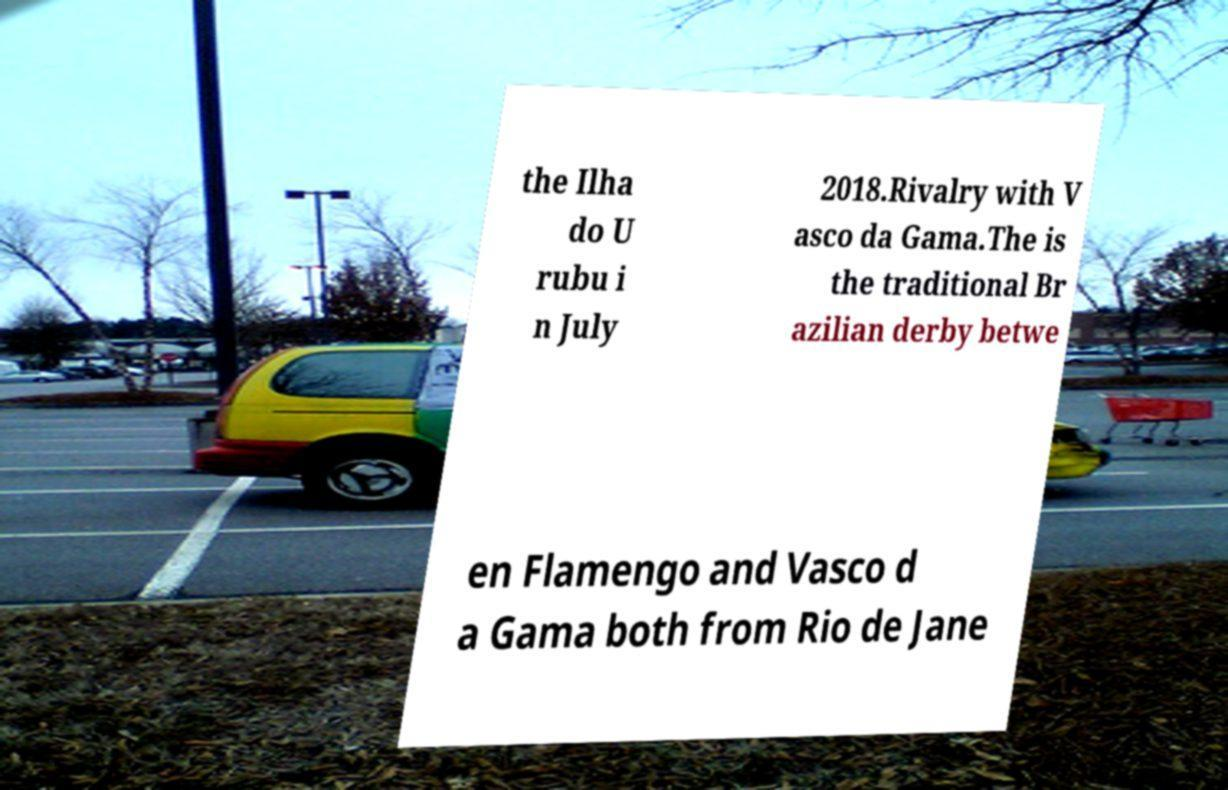I need the written content from this picture converted into text. Can you do that? the Ilha do U rubu i n July 2018.Rivalry with V asco da Gama.The is the traditional Br azilian derby betwe en Flamengo and Vasco d a Gama both from Rio de Jane 